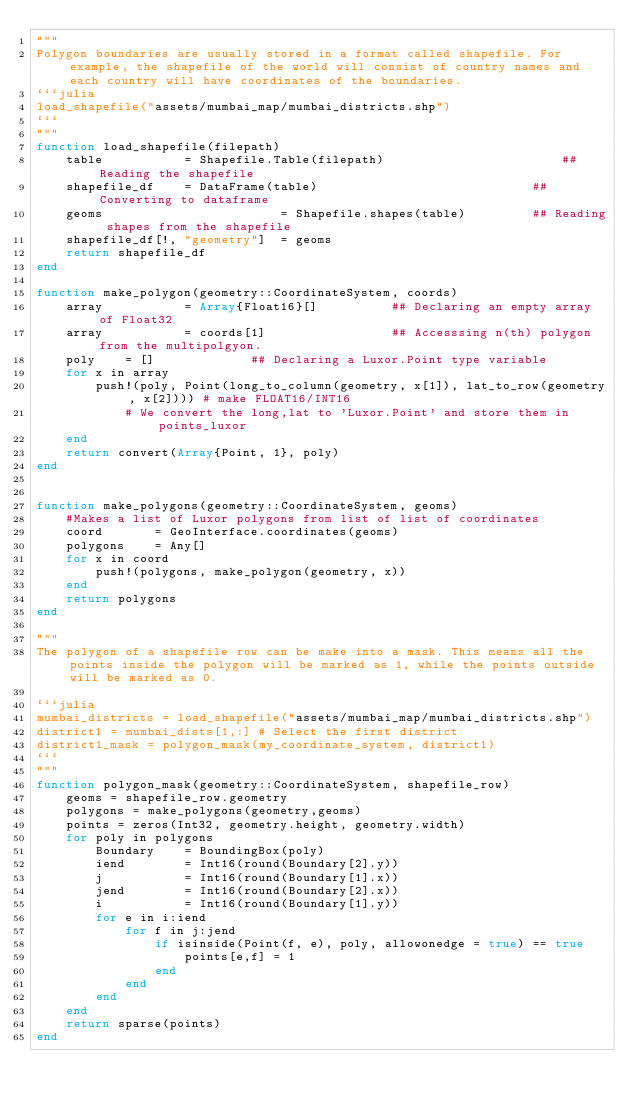<code> <loc_0><loc_0><loc_500><loc_500><_Julia_>"""
Polygon boundaries are usually stored in a format called shapefile. For example, the shapefile of the world will consist of country names and each country will have coordinates of the boundaries.   
```julia
load_shapefile("assets/mumbai_map/mumbai_districts.shp")
```
"""
function load_shapefile(filepath)
    table           = Shapefile.Table(filepath)                        ## Reading the shapefile
    shapefile_df    = DataFrame(table)                             ## Converting to dataframe         
    geoms                        = Shapefile.shapes(table)         ## Reading shapes from the shapefile
    shapefile_df[!, "geometry"]  = geoms 
    return shapefile_df
end

function make_polygon(geometry::CoordinateSystem, coords)
    array           = Array{Float16}[]          ## Declaring an empty array of Float32
    array           = coords[1]                 ## Accesssing n(th) polygon from the multipolgyon.
    poly    = []             ## Declaring a Luxor.Point type variable
    for x in array
        push!(poly, Point(long_to_column(geometry, x[1]), lat_to_row(geometry, x[2]))) # make FLOAT16/INT16
            # We convert the long,lat to 'Luxor.Point' and store them in points_luxor 
    end
    return convert(Array{Point, 1}, poly)
end


function make_polygons(geometry::CoordinateSystem, geoms)
    #Makes a list of Luxor polygons from list of list of coordinates
    coord       = GeoInterface.coordinates(geoms)
    polygons    = Any[]
    for x in coord
        push!(polygons, make_polygon(geometry, x))
    end
    return polygons
end

"""
The polygon of a shapefile row can be make into a mask. This means all the points inside the polygon will be marked as 1, while the points outside will be marked as 0.
 
```julia
mumbai_districts = load_shapefile("assets/mumbai_map/mumbai_districts.shp")
district1 = mumbai_dists[1,:] # Select the first district
district1_mask = polygon_mask(my_coordinate_system, district1)
```
"""
function polygon_mask(geometry::CoordinateSystem, shapefile_row)
    geoms = shapefile_row.geometry
    polygons = make_polygons(geometry,geoms)
    points = zeros(Int32, geometry.height, geometry.width)
    for poly in polygons
        Boundary    = BoundingBox(poly)
        iend        = Int16(round(Boundary[2].y))
        j           = Int16(round(Boundary[1].x))
        jend        = Int16(round(Boundary[2].x))
        i           = Int16(round(Boundary[1].y))
        for e in i:iend
            for f in j:jend
                if isinside(Point(f, e), poly, allowonedge = true) == true
                    points[e,f] = 1
                end
            end
        end
    end
    return sparse(points)
end</code> 